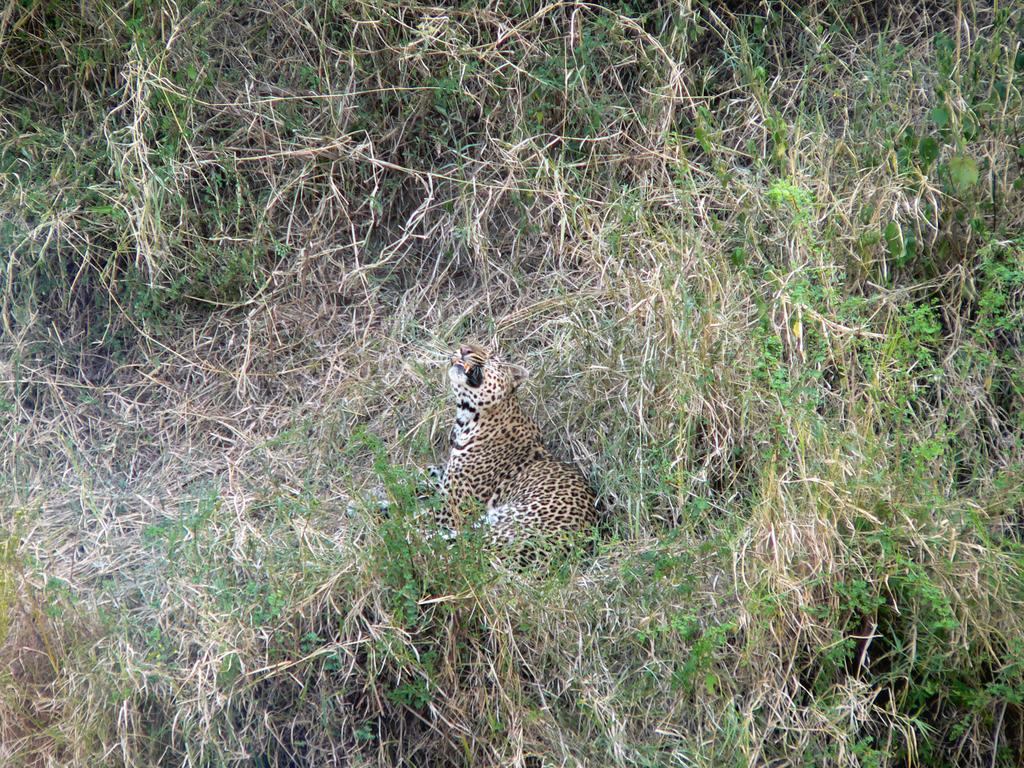What animal is in the image? There is a leopard in the image. What is the leopard standing on? The leopard is on the grass. Can you describe the time of day when the image was taken? The image appears to be taken during the day. What type of sheet is covering the leopard in the image? There is no sheet covering the leopard in the image; it is on the grass. How many members are in the group of leopards in the image? There is only one leopard present in the image. 